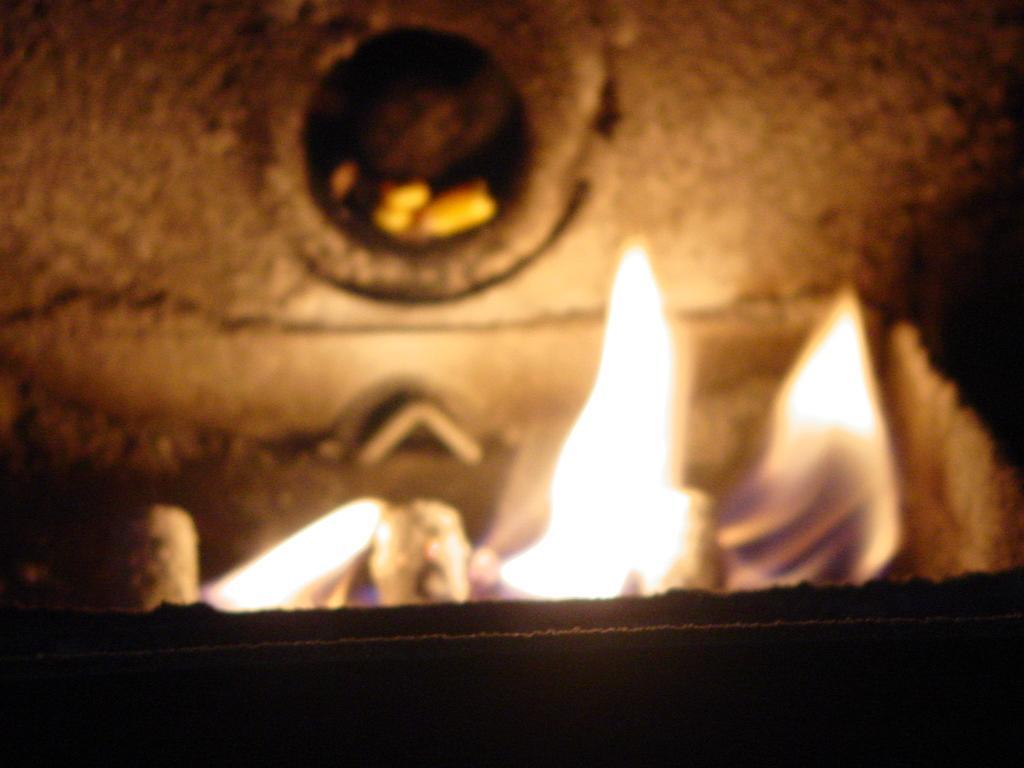Please provide a concise description of this image. In the image we can see the flames and the bottom part of the image is dark. The background is blurred. 